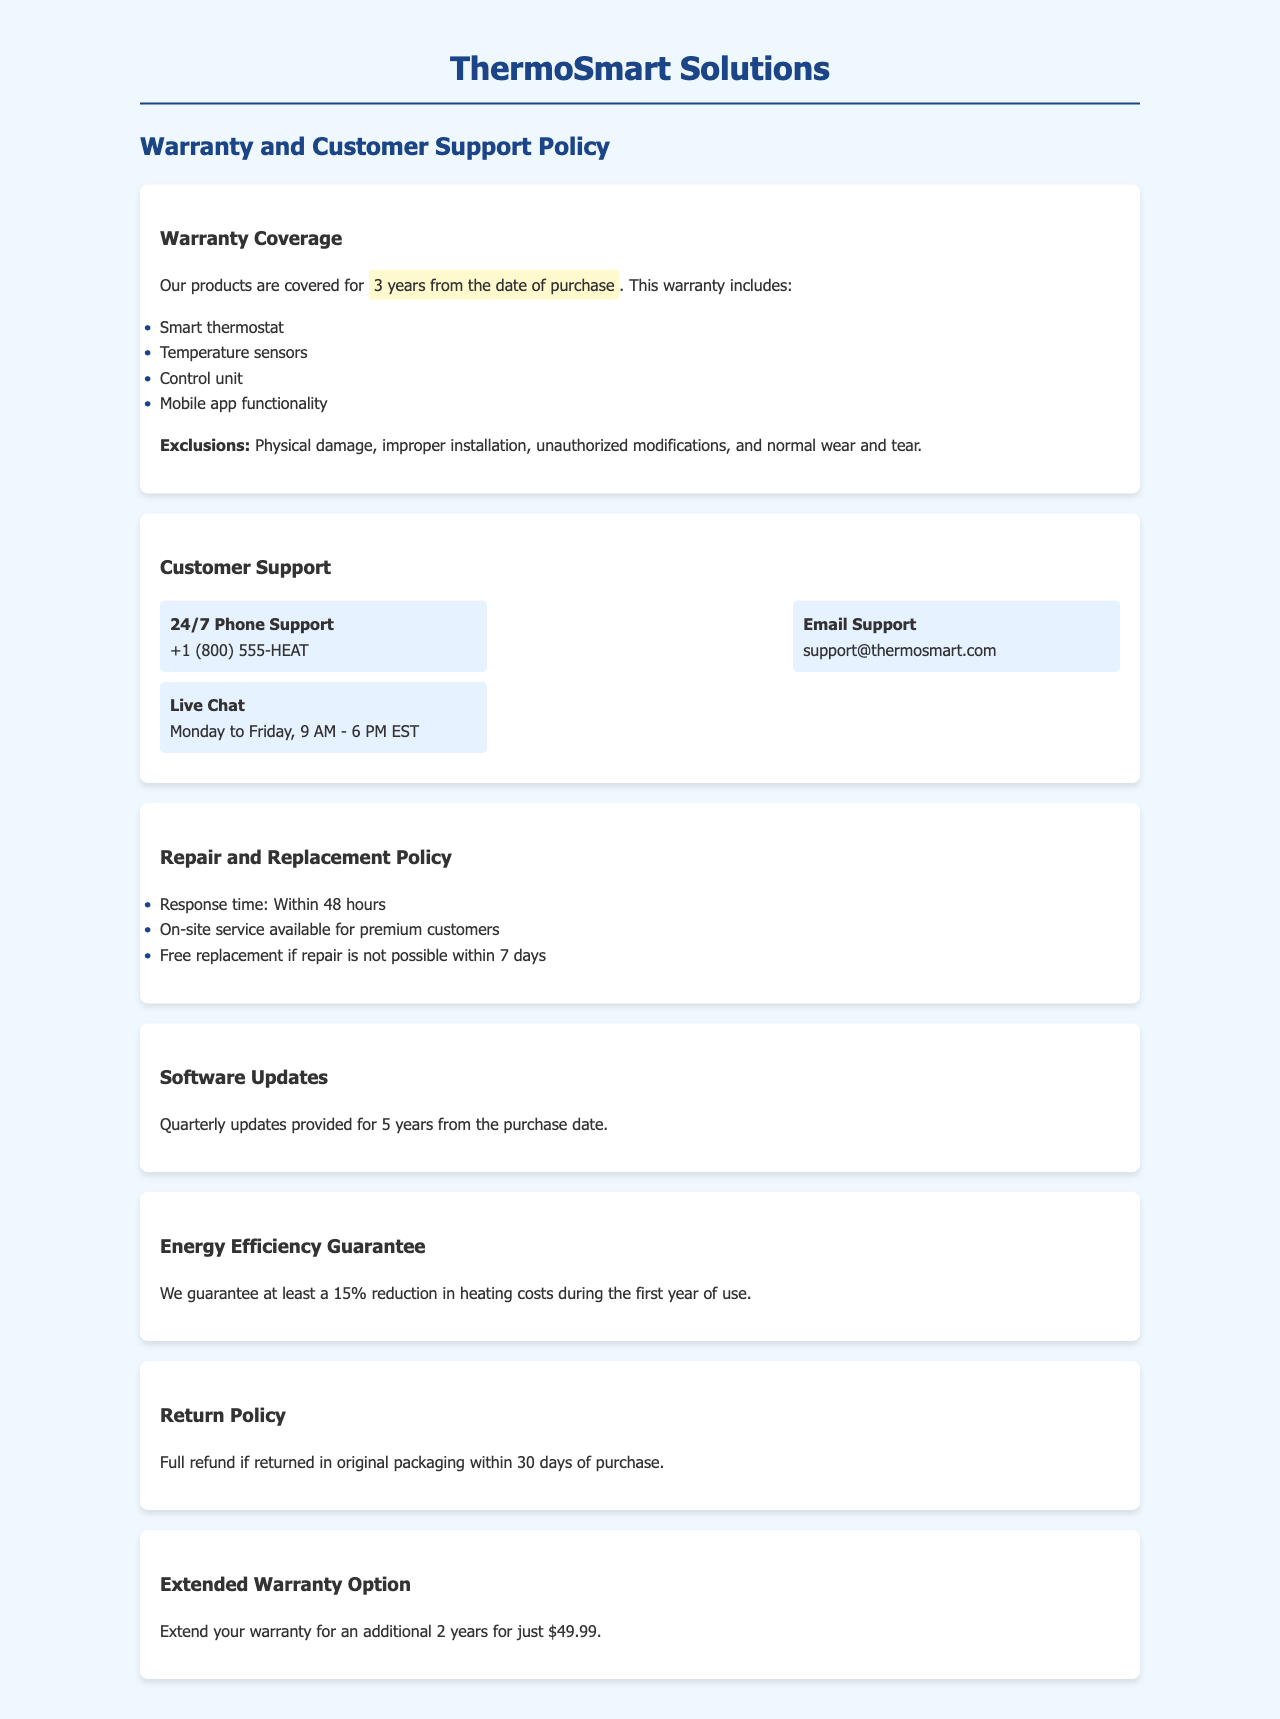What is the duration of the warranty? The warranty covers products for 3 years from the date of purchase.
Answer: 3 years What is excluded from the warranty? Exclusions include physical damage, improper installation, unauthorized modifications, and normal wear and tear.
Answer: Physical damage, improper installation, unauthorized modifications, normal wear and tear What is the response time for repairs? The document states that the response time for repairs is within 48 hours.
Answer: 48 hours How much does it cost to extend the warranty? The additional cost for extending the warranty is mentioned in the document.
Answer: $49.99 What guarantee is provided for energy efficiency? The policy guarantees a reduction in heating costs during the first year of use.
Answer: 15% reduction When are software updates provided? The policy details the frequency and duration of software updates.
Answer: Quarterly updates for 5 years What is required for a full refund? The conditions for a full refund are specified in the return policy.
Answer: Original packaging within 30 days of purchase What are the hours for live chat support? The document specifies live chat support availability days and times.
Answer: Monday to Friday, 9 AM - 6 PM EST 